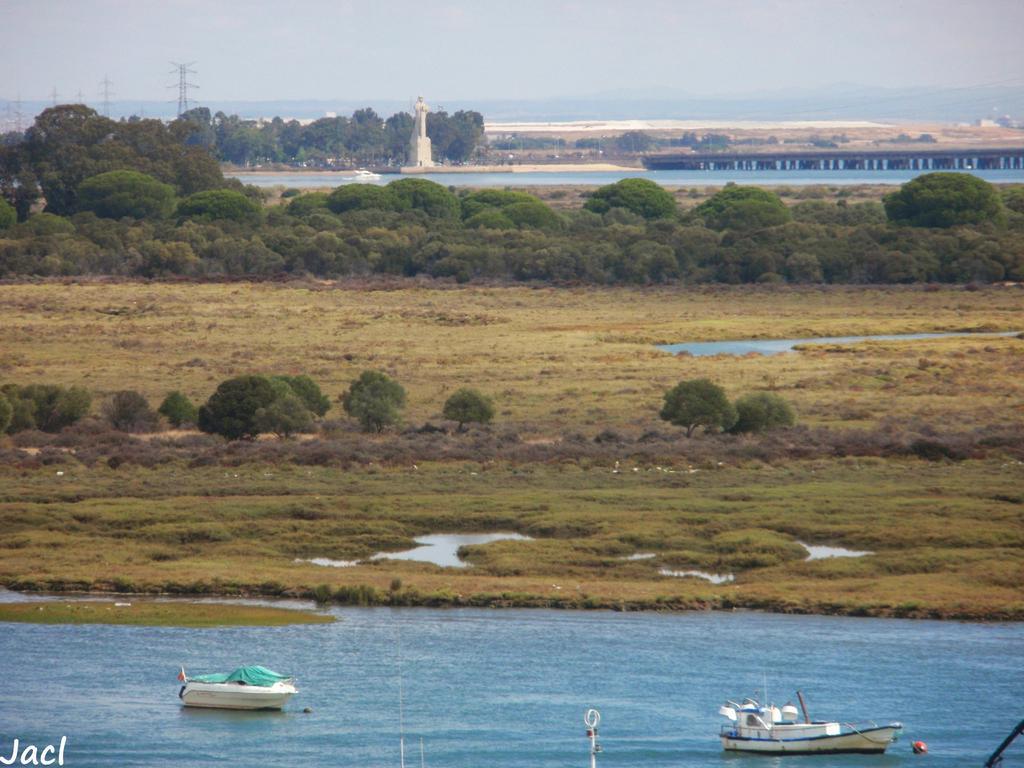In one or two sentences, can you explain what this image depicts? In this picture I can see boats on the water. I can see towers, trees and a bridge, and in the background there is the sky and there is a watermark on the image. 